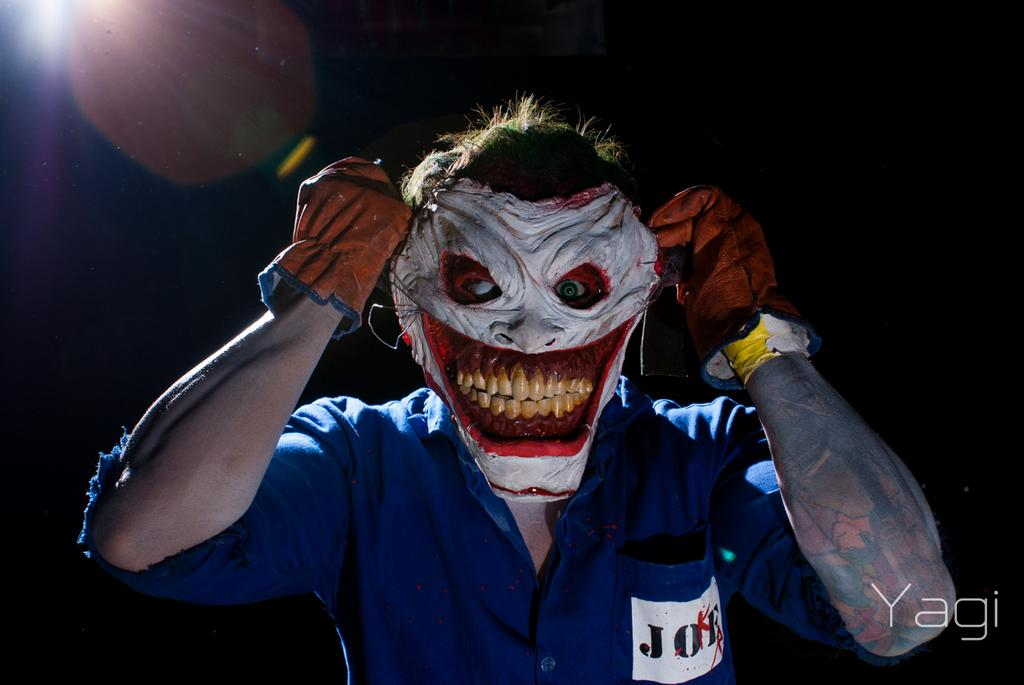What is the main subject of the image? There is a person in the image. What protective gear is the person wearing? The person is wearing a face mask and gloves. Can you describe the background of the image? The background of the image is blurry. What type of rifle can be seen in the person's hand in the image? There is no rifle present in the image. What substance is the person holding in their hand in the image? There is no substance visible in the person's hand in the image. What type of rod is the person using to stir the substance in the image? There is no rod or stirring activity present in the image. 